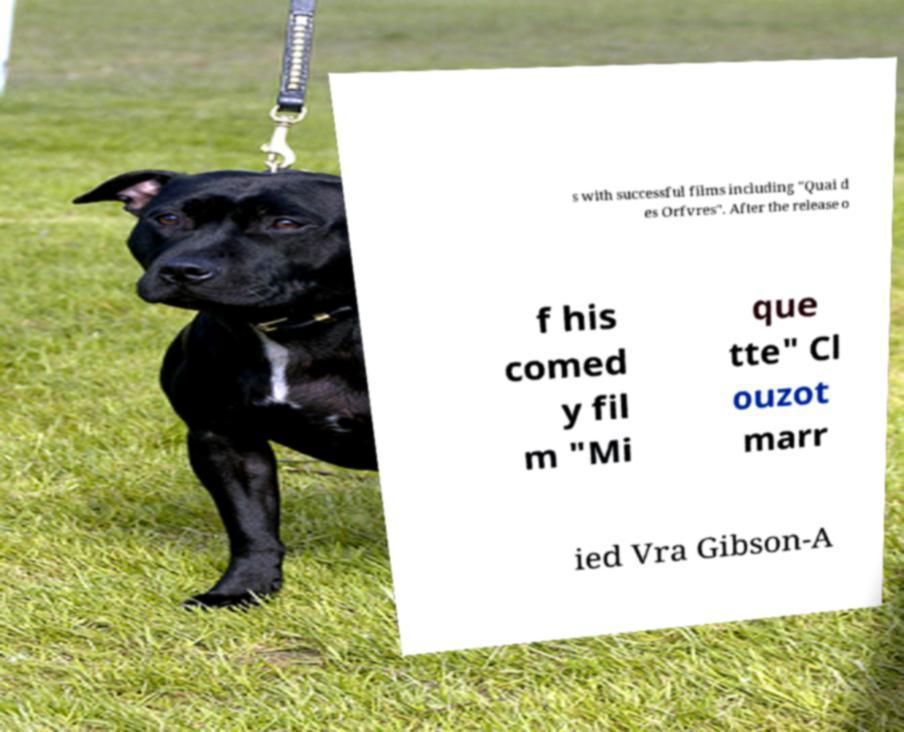Can you read and provide the text displayed in the image?This photo seems to have some interesting text. Can you extract and type it out for me? s with successful films including "Quai d es Orfvres". After the release o f his comed y fil m "Mi que tte" Cl ouzot marr ied Vra Gibson-A 